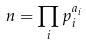Convert formula to latex. <formula><loc_0><loc_0><loc_500><loc_500>n = \prod _ { i } p _ { i } ^ { a _ { i } }</formula> 